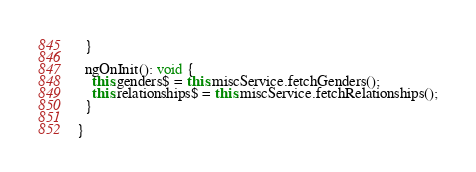<code> <loc_0><loc_0><loc_500><loc_500><_TypeScript_>  }

  ngOnInit(): void {
    this.genders$ = this.miscService.fetchGenders();
    this.relationships$ = this.miscService.fetchRelationships();
  }

}
</code> 